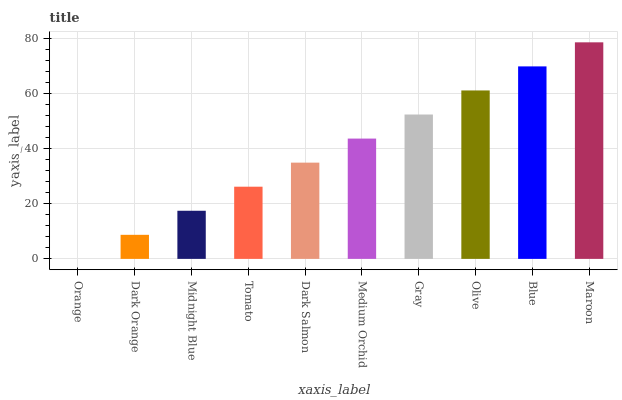Is Dark Orange the minimum?
Answer yes or no. No. Is Dark Orange the maximum?
Answer yes or no. No. Is Dark Orange greater than Orange?
Answer yes or no. Yes. Is Orange less than Dark Orange?
Answer yes or no. Yes. Is Orange greater than Dark Orange?
Answer yes or no. No. Is Dark Orange less than Orange?
Answer yes or no. No. Is Medium Orchid the high median?
Answer yes or no. Yes. Is Dark Salmon the low median?
Answer yes or no. Yes. Is Midnight Blue the high median?
Answer yes or no. No. Is Blue the low median?
Answer yes or no. No. 